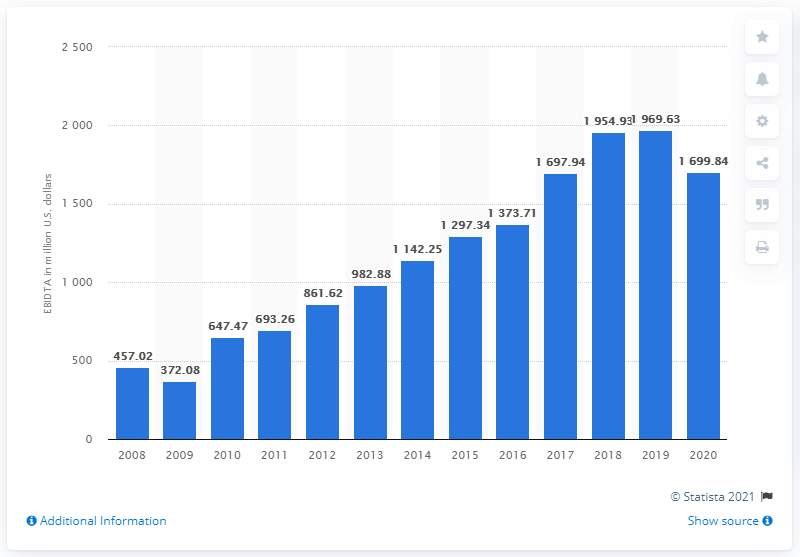Indicate a few pertinent items in this graphic. In 2020, the EBITDA of the CBRE Group was 1,699.84 dollars. 